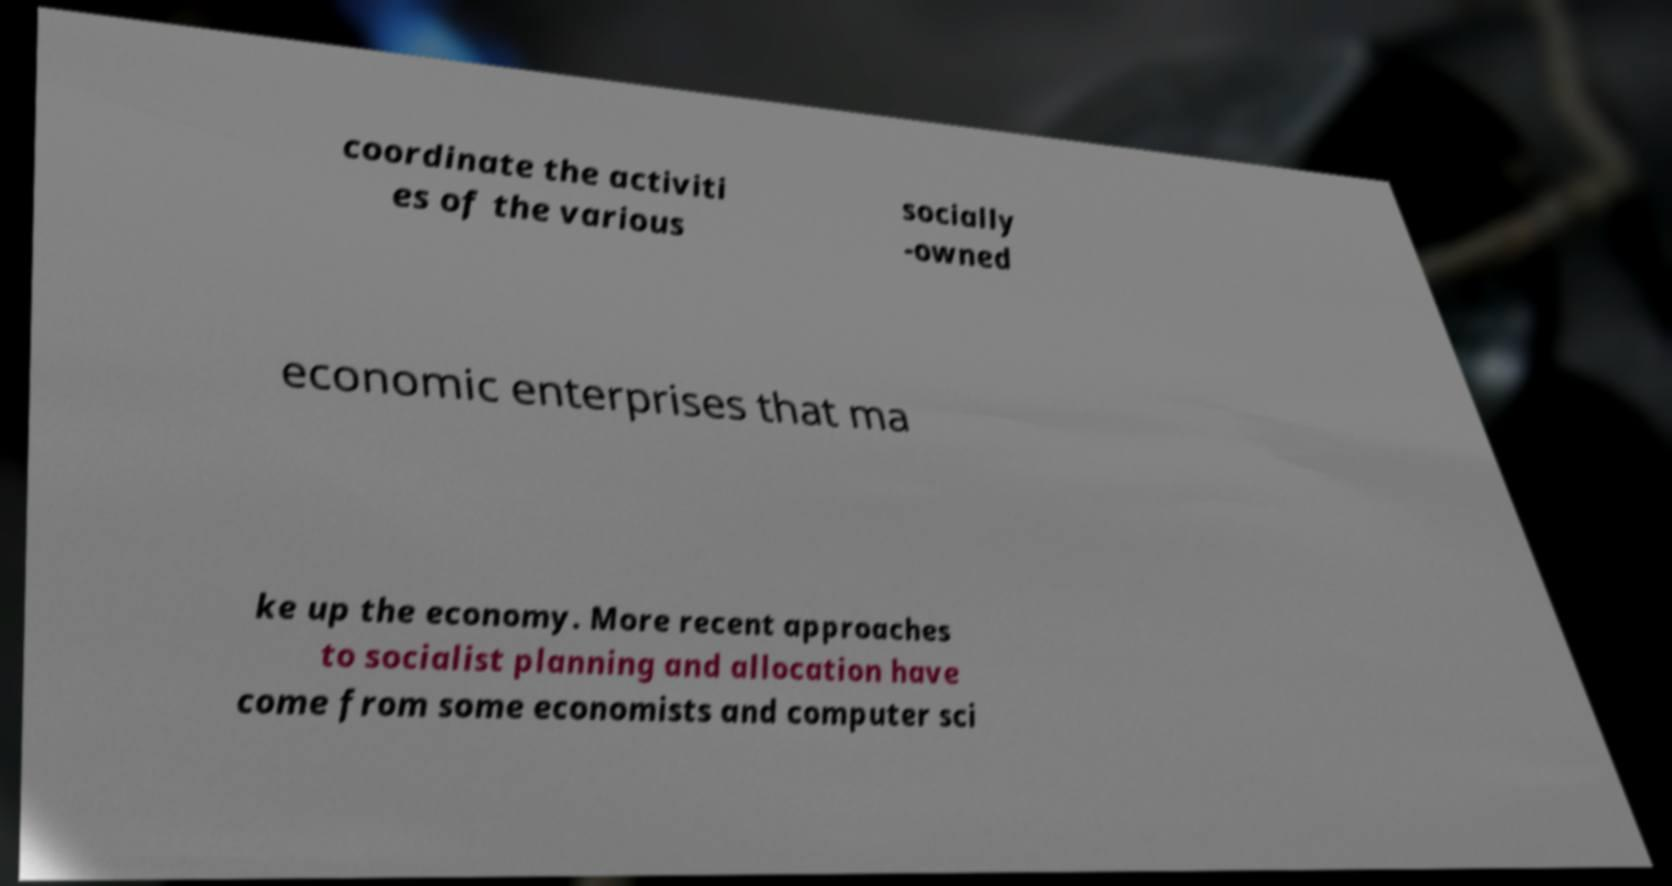Can you read and provide the text displayed in the image?This photo seems to have some interesting text. Can you extract and type it out for me? coordinate the activiti es of the various socially -owned economic enterprises that ma ke up the economy. More recent approaches to socialist planning and allocation have come from some economists and computer sci 